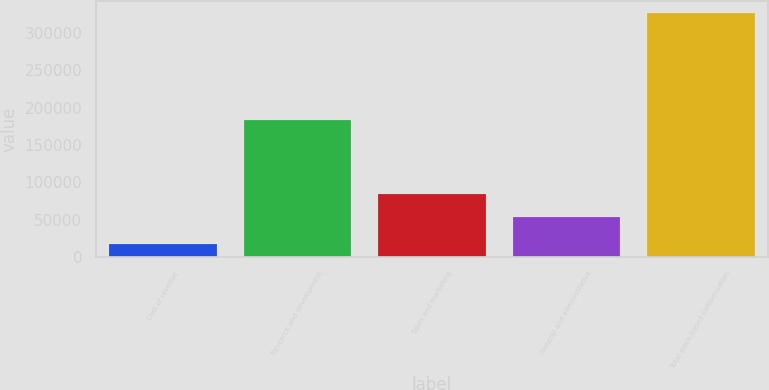Convert chart to OTSL. <chart><loc_0><loc_0><loc_500><loc_500><bar_chart><fcel>Cost of revenue<fcel>Research and development<fcel>Sales and marketing<fcel>General and administrative<fcel>Total stock-based compensation<nl><fcel>17289<fcel>183799<fcel>84728.9<fcel>53835<fcel>326228<nl></chart> 